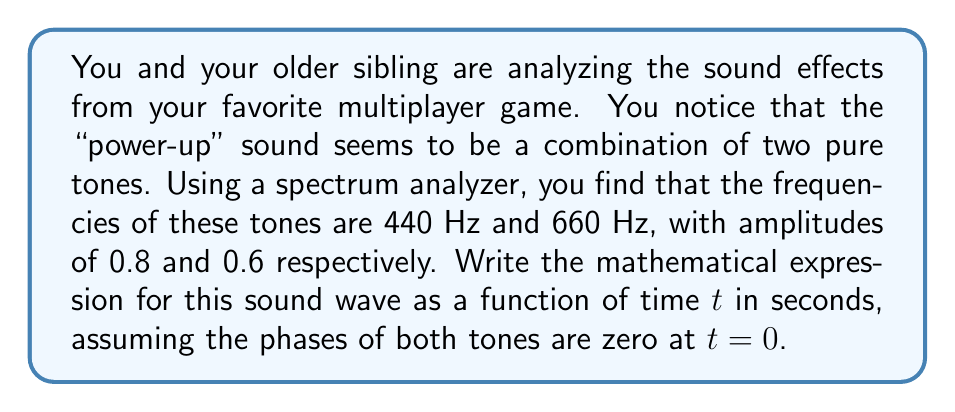Show me your answer to this math problem. Let's approach this step-by-step:

1) The general form of a sinusoidal wave is:

   $A \cos(2\pi ft + \phi)$

   where $A$ is the amplitude, $f$ is the frequency, $t$ is time, and $\phi$ is the phase.

2) We have two tones, so we'll need to add two such expressions:

   Tone 1: $f_1 = 440$ Hz, $A_1 = 0.8$
   Tone 2: $f_2 = 660$ Hz, $A_2 = 0.6$

3) Since the phases are zero at $t=0$, we can omit the phase term $\phi$.

4) Let's call our function $y(t)$. We can now write:

   $y(t) = 0.8 \cos(2\pi \cdot 440t) + 0.6 \cos(2\pi \cdot 660t)$

5) Simplifying the constants inside the cosine functions:

   $y(t) = 0.8 \cos(880\pi t) + 0.6 \cos(1320\pi t)$

This expression represents the combination of the two tones as a function of time.
Answer: $y(t) = 0.8 \cos(880\pi t) + 0.6 \cos(1320\pi t)$ 